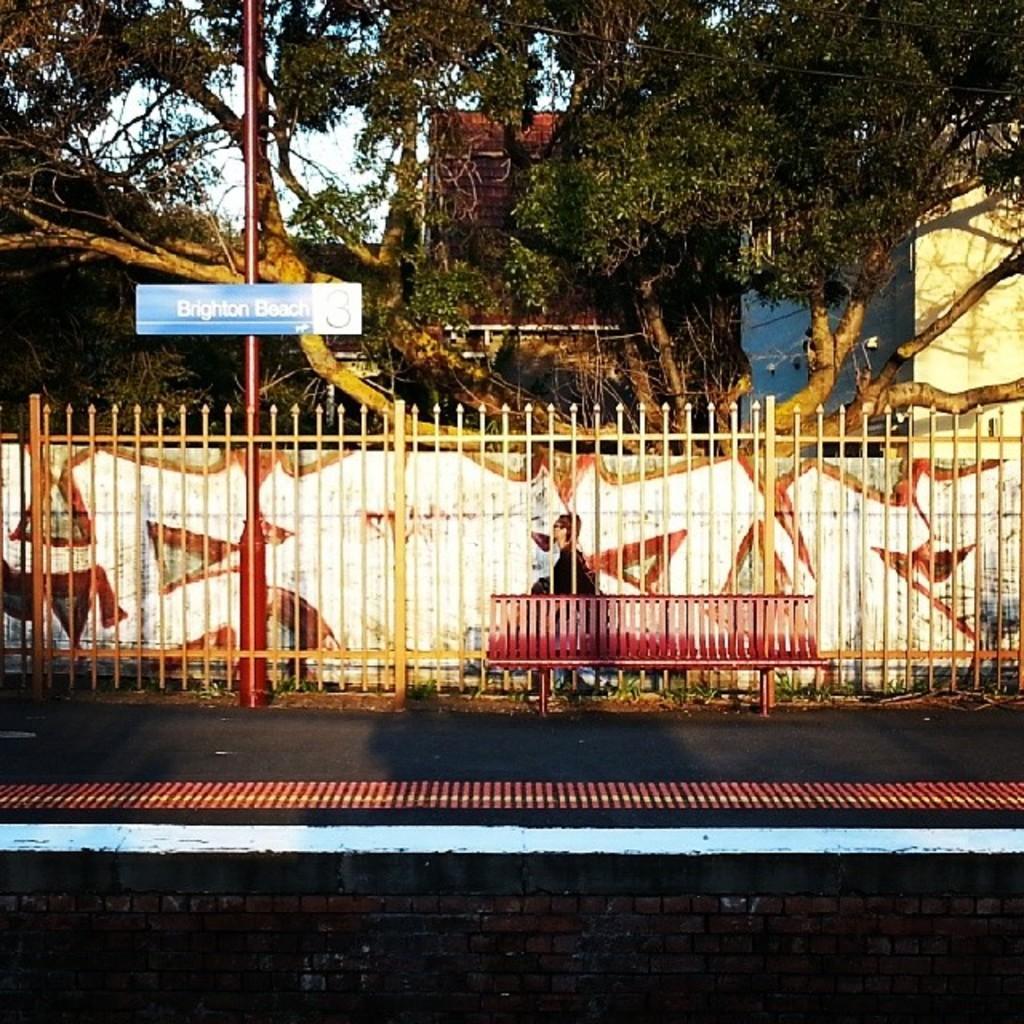Can you describe this image briefly? In this image we can see the building, trees and the sky. In front of the building we can see the wall with a design and fence. And there is the board attached to the pole. We can see the bench and road. 